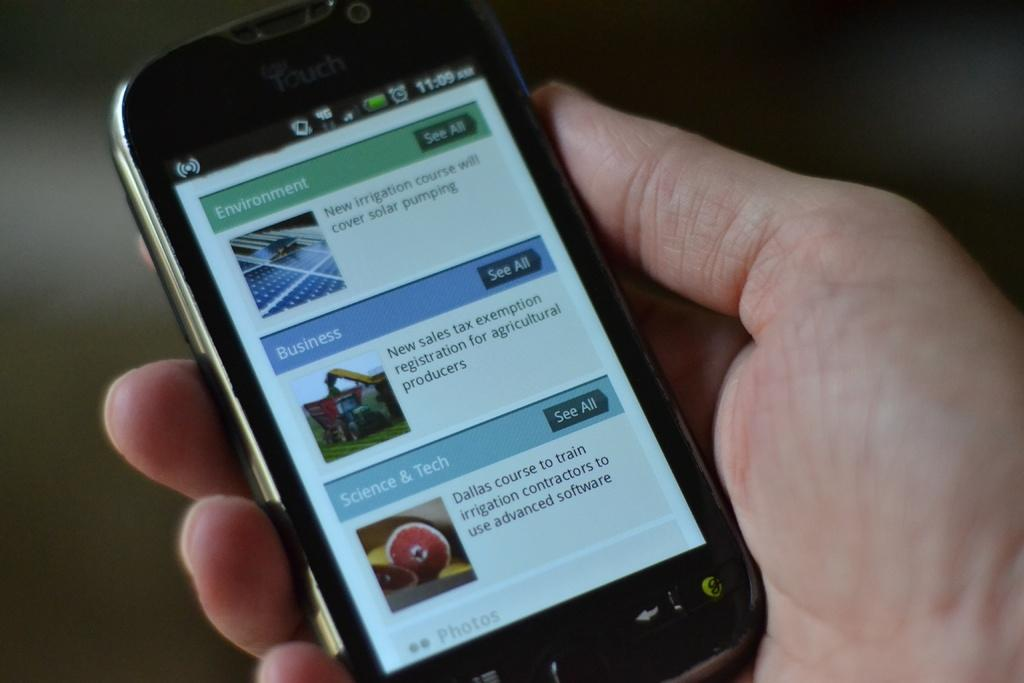<image>
Summarize the visual content of the image. An iTouch device with an entertainment link on it. 